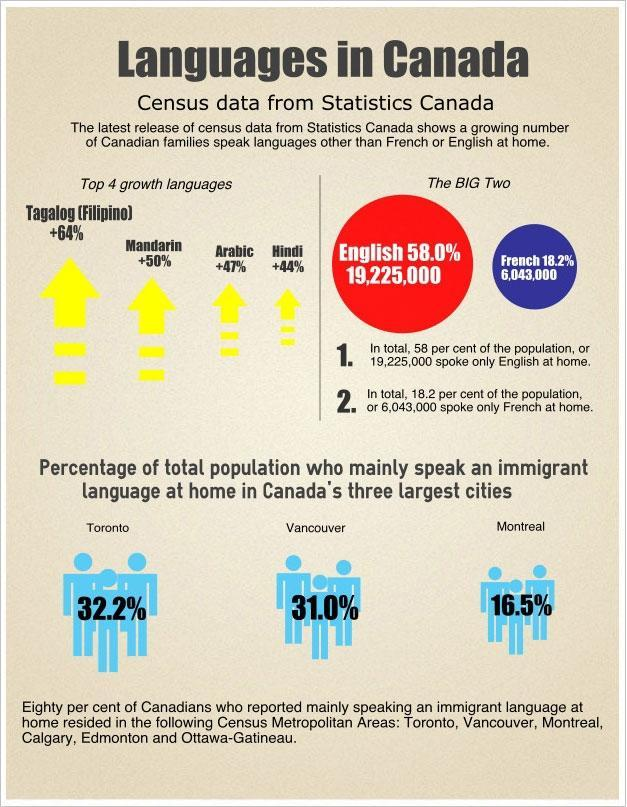What percentage of the total population mainly speak an immigrant language at home in Toronto city of Canada?
Answer the question with a short phrase. 32.2% What is the percentage increase shown in Mandarin language speaking in Canadian families? 50% What percentage of the total population mainly speak an immigrant language at home in Vancouver city of Canada? 31.0% What is the percentage increase shown in Arabic language speaking in Canadian families? +47% What percentage of the total population mainly speak an immigrant language at home in Montreal city of Canada? 16.5% Which language is spoken by 18.2% of the Canadian population? French Which language is spoken by 58% of the Canadian population? English 